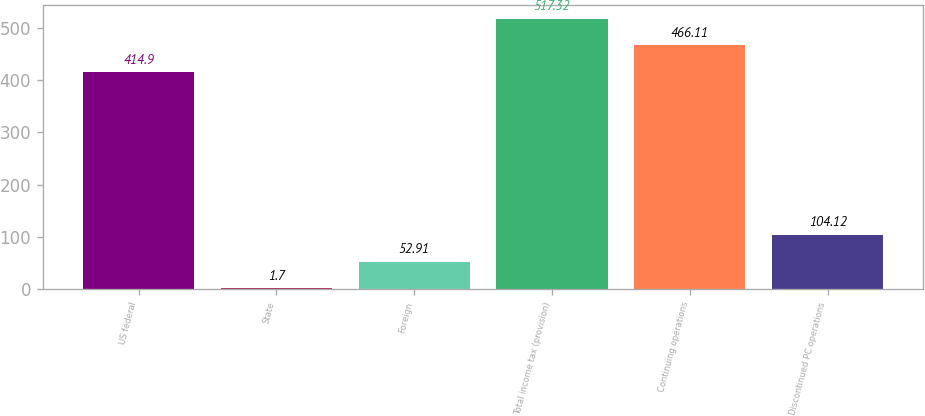<chart> <loc_0><loc_0><loc_500><loc_500><bar_chart><fcel>US federal<fcel>State<fcel>Foreign<fcel>Total income tax (provision)<fcel>Continuing operations<fcel>Discontinued PC operations<nl><fcel>414.9<fcel>1.7<fcel>52.91<fcel>517.32<fcel>466.11<fcel>104.12<nl></chart> 